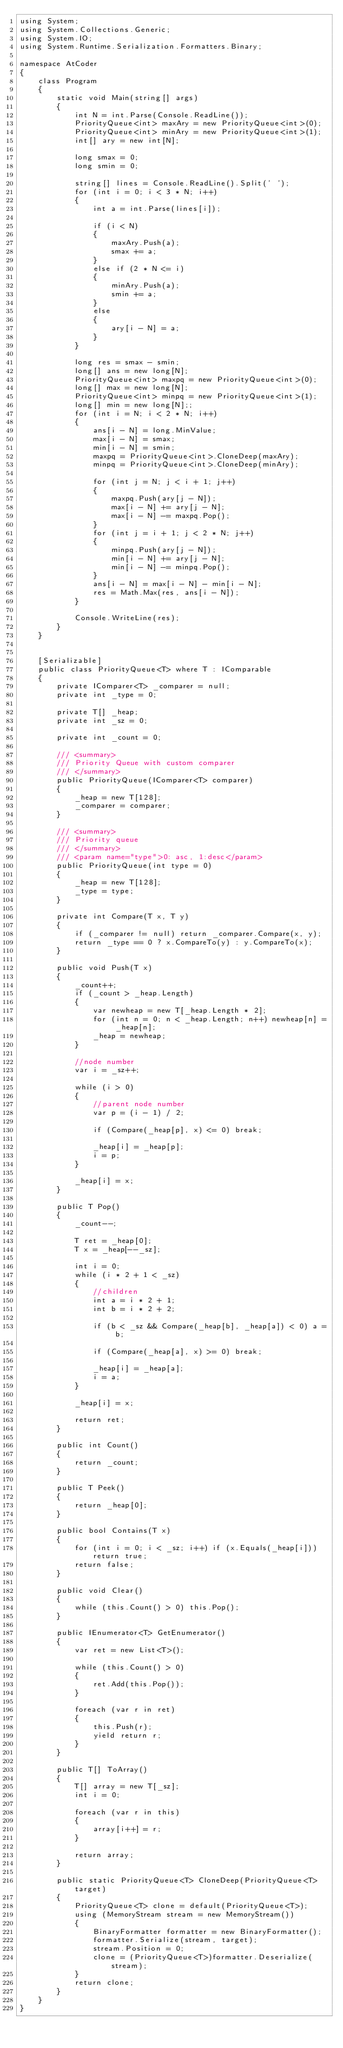Convert code to text. <code><loc_0><loc_0><loc_500><loc_500><_C#_>using System;
using System.Collections.Generic;
using System.IO;
using System.Runtime.Serialization.Formatters.Binary;

namespace AtCoder
{
    class Program
    {
        static void Main(string[] args)
        {
            int N = int.Parse(Console.ReadLine());
            PriorityQueue<int> maxAry = new PriorityQueue<int>(0);
            PriorityQueue<int> minAry = new PriorityQueue<int>(1);
            int[] ary = new int[N];

            long smax = 0;
            long smin = 0;

            string[] lines = Console.ReadLine().Split(' ');
            for (int i = 0; i < 3 * N; i++)
            {
                int a = int.Parse(lines[i]);

                if (i < N)
                {
                    maxAry.Push(a);
                    smax += a;
                }
                else if (2 * N <= i)
                {
                    minAry.Push(a);
                    smin += a;
                }
                else
                {
                    ary[i - N] = a;
                }
            }

            long res = smax - smin;
            long[] ans = new long[N];
            PriorityQueue<int> maxpq = new PriorityQueue<int>(0);
            long[] max = new long[N];
            PriorityQueue<int> minpq = new PriorityQueue<int>(1);
            long[] min = new long[N];;
            for (int i = N; i < 2 * N; i++)
            {
                ans[i - N] = long.MinValue;
                max[i - N] = smax;
                min[i - N] = smin;
                maxpq = PriorityQueue<int>.CloneDeep(maxAry);
                minpq = PriorityQueue<int>.CloneDeep(minAry);

                for (int j = N; j < i + 1; j++)
                {
                    maxpq.Push(ary[j - N]);
                    max[i - N] += ary[j - N];
                    max[i - N] -= maxpq.Pop();
                }
                for (int j = i + 1; j < 2 * N; j++)
                {
                    minpq.Push(ary[j - N]);
                    min[i - N] += ary[j - N];
                    min[i - N] -= minpq.Pop();
                }
                ans[i - N] = max[i - N] - min[i - N];
                res = Math.Max(res, ans[i - N]);
            }

            Console.WriteLine(res);
        }
    }


    [Serializable]
    public class PriorityQueue<T> where T : IComparable
    {
        private IComparer<T> _comparer = null;
        private int _type = 0;

        private T[] _heap;
        private int _sz = 0;

        private int _count = 0;

        /// <summary>
        /// Priority Queue with custom comparer
        /// </summary>
        public PriorityQueue(IComparer<T> comparer)
        {
            _heap = new T[128];
            _comparer = comparer;
        }

        /// <summary>
        /// Priority queue
        /// </summary>
        /// <param name="type">0: asc, 1:desc</param>
        public PriorityQueue(int type = 0)
        {
            _heap = new T[128];
            _type = type;
        }

        private int Compare(T x, T y)
        {
            if (_comparer != null) return _comparer.Compare(x, y);
            return _type == 0 ? x.CompareTo(y) : y.CompareTo(x);
        }

        public void Push(T x)
        {
            _count++;
            if (_count > _heap.Length)
            {
                var newheap = new T[_heap.Length * 2];
                for (int n = 0; n < _heap.Length; n++) newheap[n] = _heap[n];
                _heap = newheap;
            }

            //node number
            var i = _sz++;

            while (i > 0)
            {
                //parent node number
                var p = (i - 1) / 2;

                if (Compare(_heap[p], x) <= 0) break;

                _heap[i] = _heap[p];
                i = p;
            }

            _heap[i] = x;
        }

        public T Pop()
        {
            _count--;

            T ret = _heap[0];
            T x = _heap[--_sz];

            int i = 0;
            while (i * 2 + 1 < _sz)
            {
                //children
                int a = i * 2 + 1;
                int b = i * 2 + 2;

                if (b < _sz && Compare(_heap[b], _heap[a]) < 0) a = b;

                if (Compare(_heap[a], x) >= 0) break;

                _heap[i] = _heap[a];
                i = a;
            }

            _heap[i] = x;

            return ret;
        }

        public int Count()
        {
            return _count;
        }

        public T Peek()
        {
            return _heap[0];
        }

        public bool Contains(T x)
        {
            for (int i = 0; i < _sz; i++) if (x.Equals(_heap[i])) return true;
            return false;
        }

        public void Clear()
        {
            while (this.Count() > 0) this.Pop();
        }

        public IEnumerator<T> GetEnumerator()
        {
            var ret = new List<T>();

            while (this.Count() > 0)
            {
                ret.Add(this.Pop());
            }

            foreach (var r in ret)
            {
                this.Push(r);
                yield return r;
            }
        }

        public T[] ToArray()
        {
            T[] array = new T[_sz];
            int i = 0;

            foreach (var r in this)
            {
                array[i++] = r;
            }

            return array;
        }
        
        public static PriorityQueue<T> CloneDeep(PriorityQueue<T> target)
        {
            PriorityQueue<T> clone = default(PriorityQueue<T>);
            using (MemoryStream stream = new MemoryStream())
            {
                BinaryFormatter formatter = new BinaryFormatter();
                formatter.Serialize(stream, target);
                stream.Position = 0;
                clone = (PriorityQueue<T>)formatter.Deserialize(stream);
            }
            return clone;
        }
    }
}
</code> 